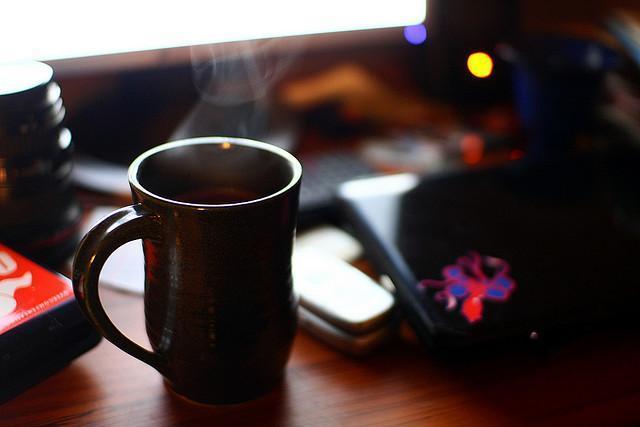How many people are there?
Give a very brief answer. 0. 